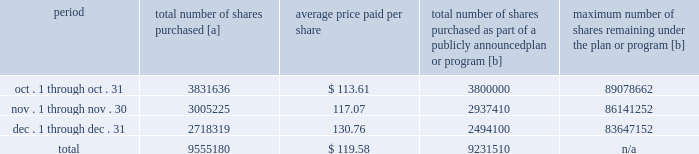Five-year performance comparison 2013 the following graph provides an indicator of cumulative total shareholder returns for the corporation as compared to the peer group index ( described above ) , the dj trans , and the s&p 500 .
The graph assumes that $ 100 was invested in the common stock of union pacific corporation and each index on december 31 , 2012 and that all dividends were reinvested .
The information below is historical in nature and is not necessarily indicative of future performance .
Purchases of equity securities 2013 during 2017 , we repurchased 37122405 shares of our common stock at an average price of $ 110.50 .
The table presents common stock repurchases during each month for the fourth quarter of 2017 : period total number of shares purchased [a] average price paid per share total number of shares purchased as part of a publicly announced plan or program [b] maximum number of shares remaining under the plan or program [b] .
[a] total number of shares purchased during the quarter includes approximately 323670 shares delivered or attested to upc by employees to pay stock option exercise prices , satisfy excess tax withholding obligations for stock option exercises or vesting of retention units , and pay withholding obligations for vesting of retention shares .
[b] effective january 1 , 2017 , our board of directors authorized the repurchase of up to 120 million shares of our common stock by december 31 , 2020 .
These repurchases may be made on the open market or through other transactions .
Our management has sole discretion with respect to determining the timing and amount of these transactions. .
What percent of the total shares purchased during the fourth quarter of 2017 were purchased in december? 
Computations: (2718319 / 9555180)
Answer: 0.28449. 